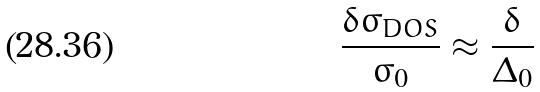Convert formula to latex. <formula><loc_0><loc_0><loc_500><loc_500>\frac { \delta \sigma _ { D O S } } { \sigma _ { 0 } } \approx \frac { \delta } { \Delta _ { 0 } }</formula> 